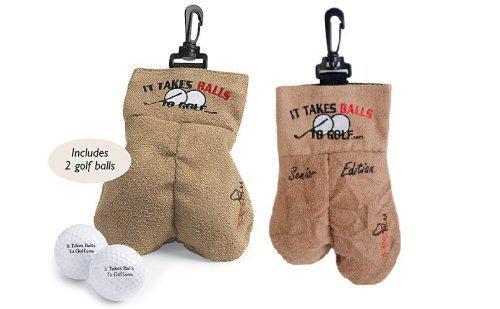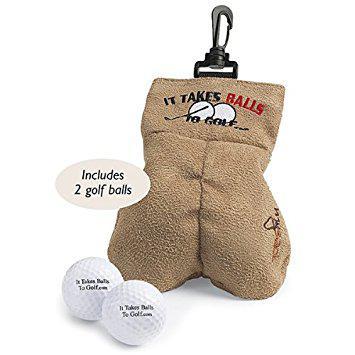The first image is the image on the left, the second image is the image on the right. Assess this claim about the two images: "An image shows one brown sack next to a pair of balls.". Correct or not? Answer yes or no. Yes. The first image is the image on the left, the second image is the image on the right. Examine the images to the left and right. Is the description "There are exactly 4 golf balls." accurate? Answer yes or no. Yes. 